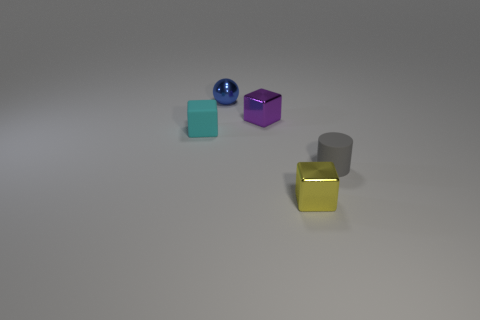What number of other things are made of the same material as the tiny gray cylinder?
Provide a succinct answer. 1. What color is the tiny thing to the right of the small object that is in front of the tiny gray thing?
Provide a succinct answer. Gray. What number of other things are there of the same shape as the yellow metal thing?
Provide a short and direct response. 2. Are there any tiny spheres that have the same material as the cylinder?
Ensure brevity in your answer.  No. What material is the gray cylinder that is the same size as the blue metal sphere?
Keep it short and to the point. Rubber. What color is the matte thing on the right side of the purple cube behind the yellow cube in front of the tiny gray matte object?
Give a very brief answer. Gray. Do the tiny rubber thing that is in front of the small matte cube and the rubber thing left of the yellow metal object have the same shape?
Make the answer very short. No. What number of small yellow metallic cylinders are there?
Provide a succinct answer. 0. What color is the matte cylinder that is the same size as the cyan object?
Give a very brief answer. Gray. Are the tiny block that is on the left side of the small blue object and the object that is in front of the small rubber cylinder made of the same material?
Provide a succinct answer. No. 